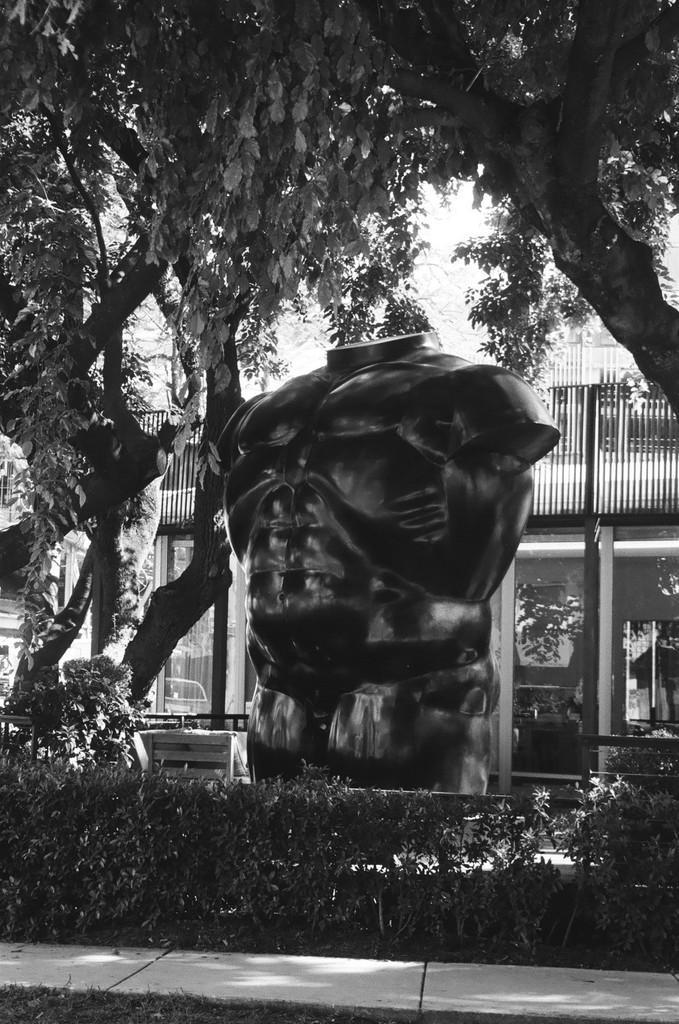Please provide a concise description of this image. This is a black and white image. At the center of the image there is a statue and there are trees and plants. In the background there is a building. 